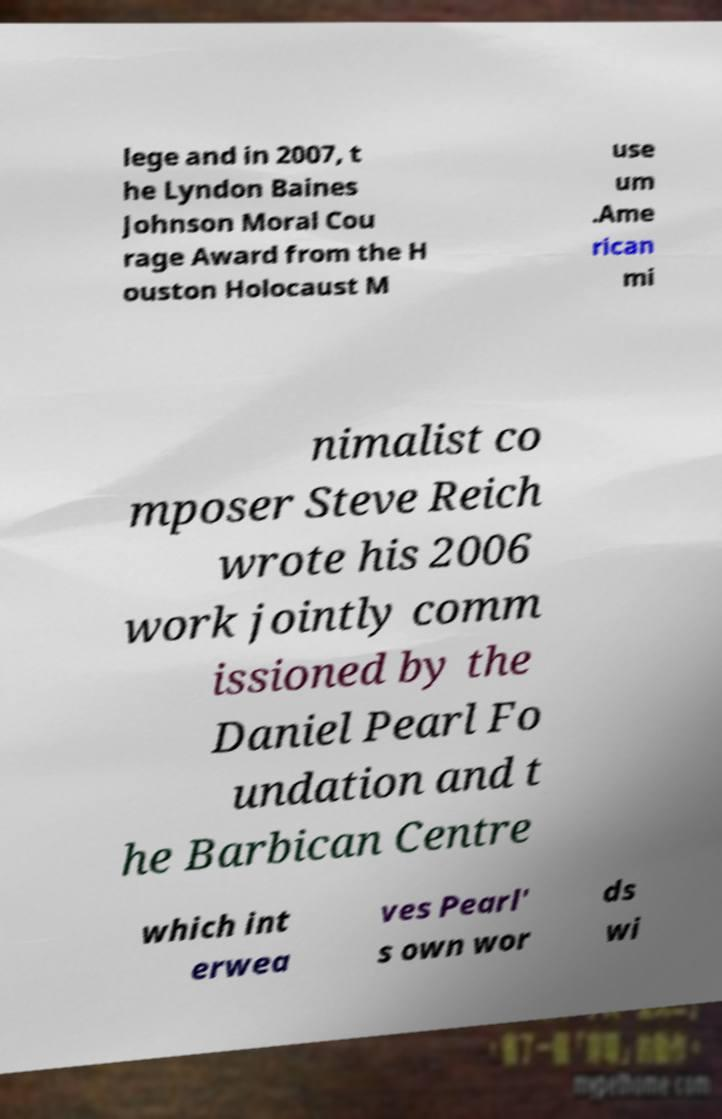What messages or text are displayed in this image? I need them in a readable, typed format. lege and in 2007, t he Lyndon Baines Johnson Moral Cou rage Award from the H ouston Holocaust M use um .Ame rican mi nimalist co mposer Steve Reich wrote his 2006 work jointly comm issioned by the Daniel Pearl Fo undation and t he Barbican Centre which int erwea ves Pearl' s own wor ds wi 